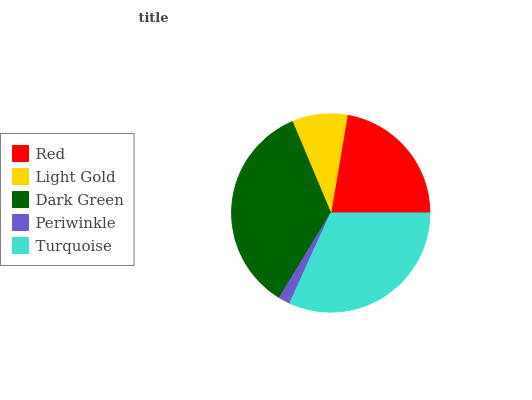Is Periwinkle the minimum?
Answer yes or no. Yes. Is Dark Green the maximum?
Answer yes or no. Yes. Is Light Gold the minimum?
Answer yes or no. No. Is Light Gold the maximum?
Answer yes or no. No. Is Red greater than Light Gold?
Answer yes or no. Yes. Is Light Gold less than Red?
Answer yes or no. Yes. Is Light Gold greater than Red?
Answer yes or no. No. Is Red less than Light Gold?
Answer yes or no. No. Is Red the high median?
Answer yes or no. Yes. Is Red the low median?
Answer yes or no. Yes. Is Turquoise the high median?
Answer yes or no. No. Is Turquoise the low median?
Answer yes or no. No. 